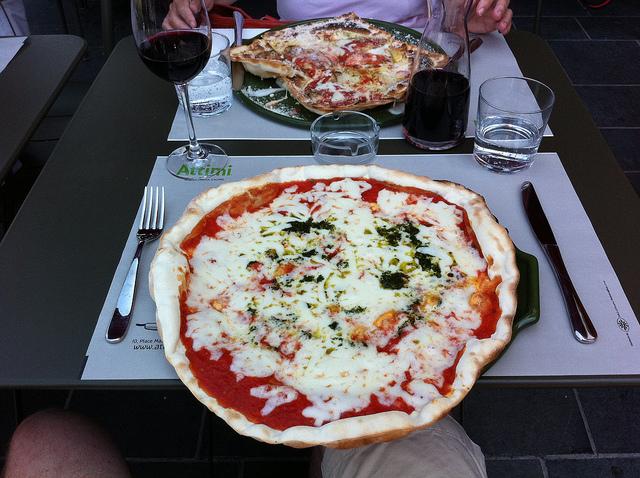How many glasses are on the table?
Short answer required. 4. Is there a spoon on the table?
Short answer required. No. What material is the table made of?
Short answer required. Wood. How many pizzas are on the table?
Give a very brief answer. 2. Are these large pizzas?
Keep it brief. Yes. 